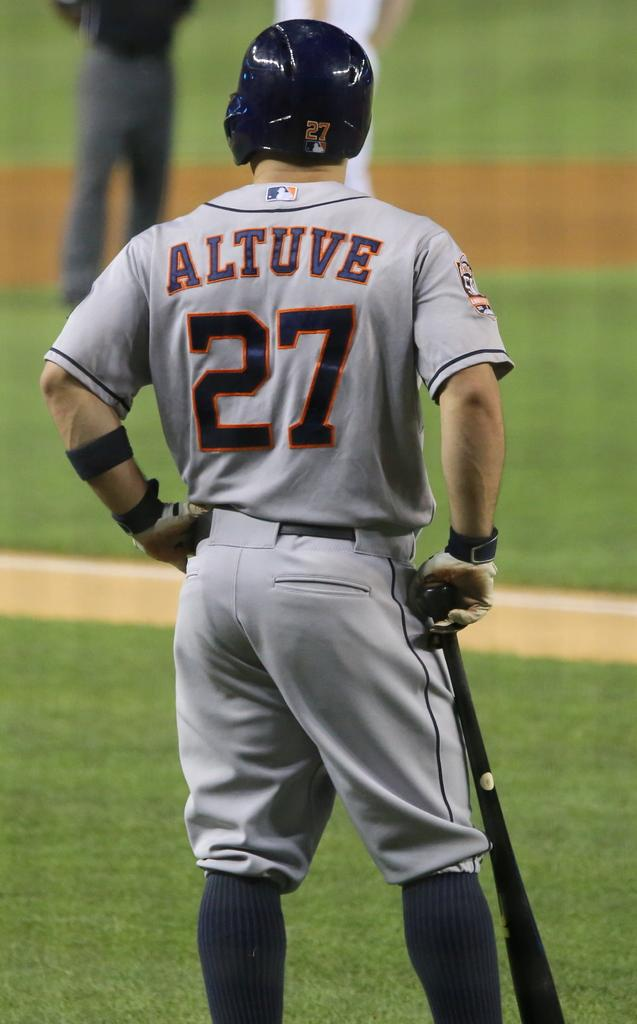<image>
Provide a brief description of the given image. Player Altuve who wears number 27 gets ready to bat. 